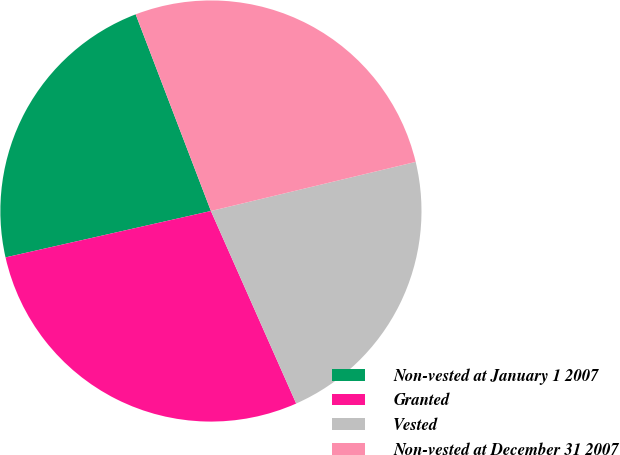Convert chart to OTSL. <chart><loc_0><loc_0><loc_500><loc_500><pie_chart><fcel>Non-vested at January 1 2007<fcel>Granted<fcel>Vested<fcel>Non-vested at December 31 2007<nl><fcel>22.72%<fcel>28.1%<fcel>22.11%<fcel>27.07%<nl></chart> 